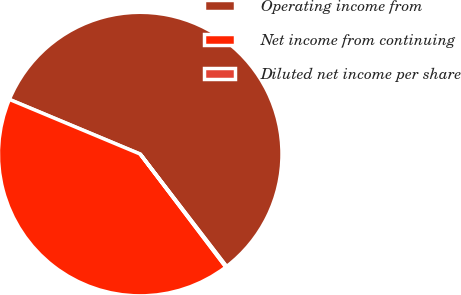Convert chart to OTSL. <chart><loc_0><loc_0><loc_500><loc_500><pie_chart><fcel>Operating income from<fcel>Net income from continuing<fcel>Diluted net income per share<nl><fcel>58.27%<fcel>41.62%<fcel>0.11%<nl></chart> 